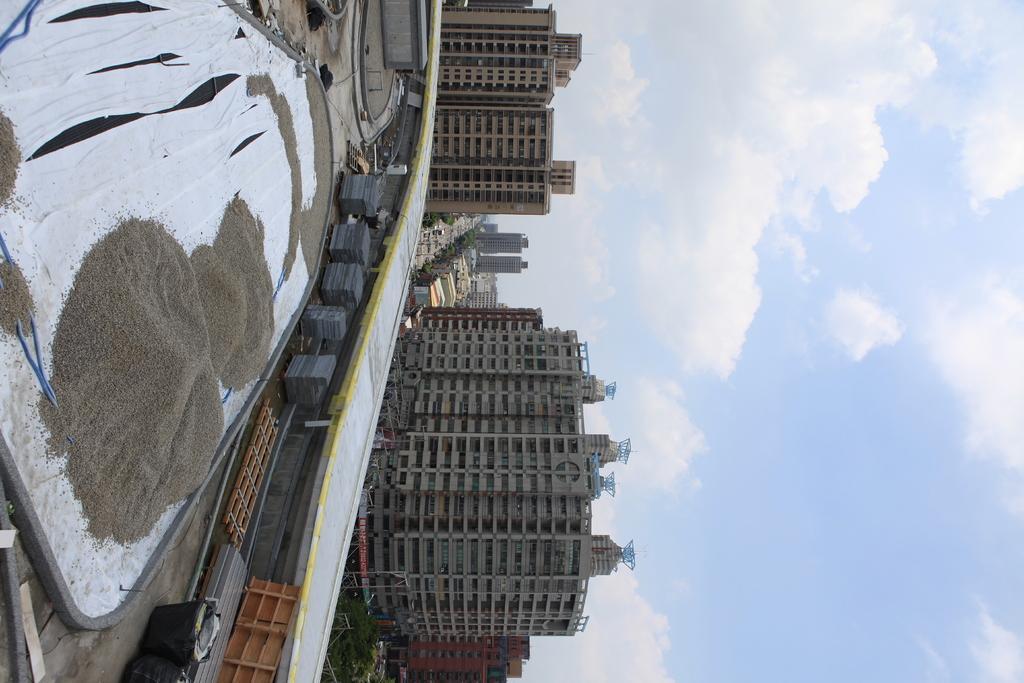How would you summarize this image in a sentence or two? In this picture we can observe a heap which is in brown color. We can observe a white color path here. In the background there are buildings and trees. There is a sky with some clouds. 